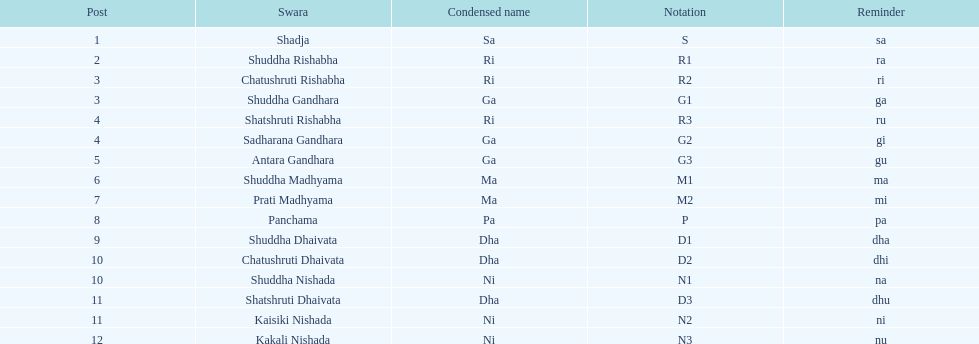What is the total number of positions listed? 16. 